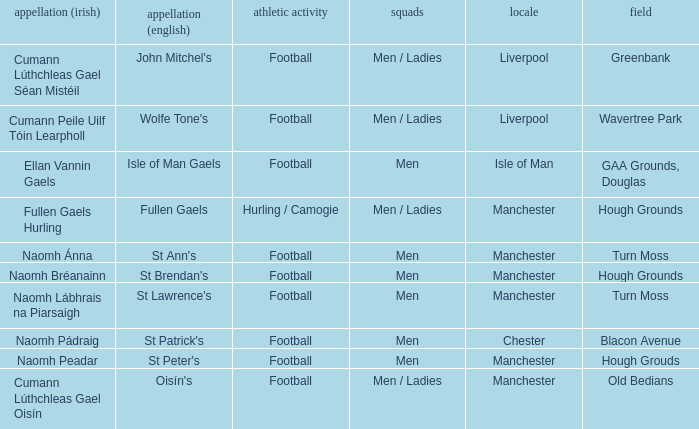What Pitch is located at Isle of Man? GAA Grounds, Douglas. 